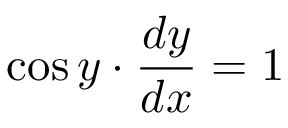Convert formula to latex. <formula><loc_0><loc_0><loc_500><loc_500>\cos y \cdot { \frac { d y } { d x } } = 1 \,</formula> 